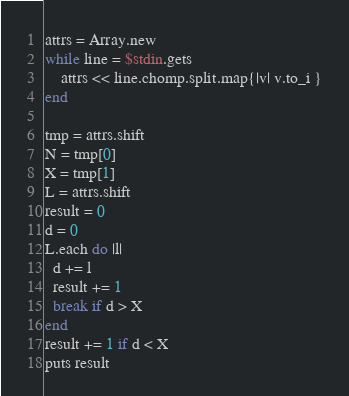Convert code to text. <code><loc_0><loc_0><loc_500><loc_500><_Ruby_>attrs = Array.new
while line = $stdin.gets
    attrs << line.chomp.split.map{|v| v.to_i }
end

tmp = attrs.shift
N = tmp[0]
X = tmp[1]
L = attrs.shift
result = 0
d = 0
L.each do |l|
  d += l
  result += 1
  break if d > X
end
result += 1 if d < X
puts result</code> 